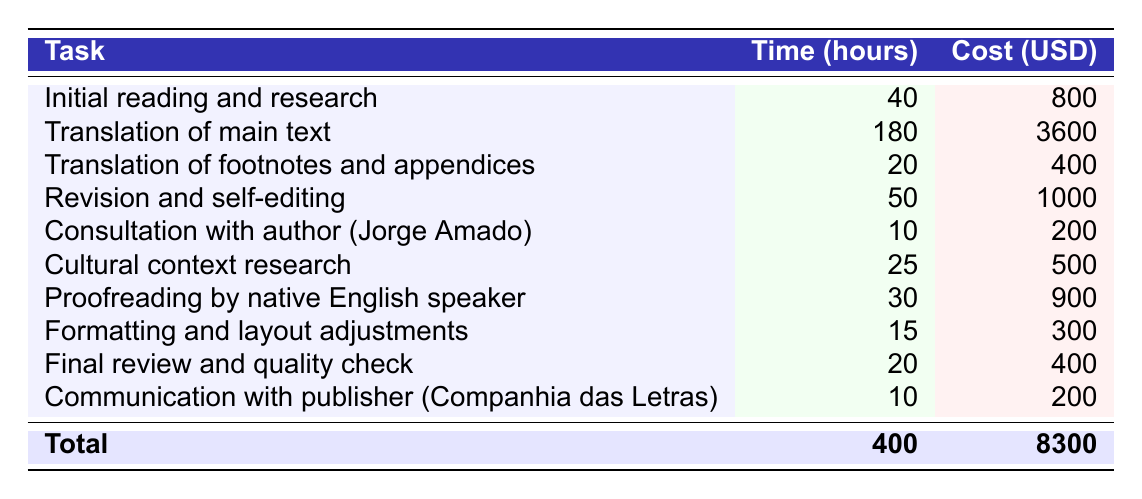What is the total time estimated for translating the novel? The table lists each task with the time allocated. Adding all the time values together: 40 + 180 + 20 + 50 + 10 + 25 + 30 + 15 + 20 + 10 = 400 hours.
Answer: 400 hours How much does the revision and self-editing cost? According to the table, the cost listed for revision and self-editing is 1000 USD.
Answer: 1000 USD What task has the highest cost associated with it? By comparing all the costs in the table, the task "Translation of main text" has the highest cost at 3600 USD.
Answer: Translation of main text What is the average cost per task if we consider all tasks? There are 10 tasks listed in the table. The total cost is 8300 USD. To find the average: 8300 USD / 10 = 830 USD per task.
Answer: 830 USD Is the cost for cultural context research less than the cost for proofreading? The cost for cultural context research is 500 USD, and the cost for proofreading is 900 USD. Since 500 is less than 900, the answer is yes.
Answer: Yes What is the difference in time between the translation of the main text and the final review? The time for the translation of the main text is 180 hours, while the final review is 20 hours. The difference is 180 - 20 = 160 hours.
Answer: 160 hours If a translator were to take 8 hours per day, how many days would it take to complete the initial reading and research? The initial reading and research takes 40 hours. Dividing this by 8 hours per day gives: 40 / 8 = 5 days.
Answer: 5 days What percentage of the total budget is allocated to the translation of the main text? The cost for the translation of the main text is 3600 USD. To find the percentage of the total budget: (3600 / 8300) * 100 = 43.37%.
Answer: 43.37% How many tasks take less than 30 hours to complete? By reviewing the time for each task, "Consultation with author," "Cultural context research," "Formatting and layout adjustments," and "Communication with publisher" take less than 30 hours. There are 4 tasks that fit this criterion.
Answer: 4 tasks What is the total cost for the tasks that involve consultation or communication? The tasks involving consultation are "Consultation with author" (200 USD) and "Communication with publisher" (200 USD), giving a total of 200 + 200 = 400 USD.
Answer: 400 USD 